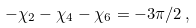<formula> <loc_0><loc_0><loc_500><loc_500>- \chi _ { 2 } - \chi _ { 4 } - \chi _ { 6 } = - { 3 \pi } / { 2 } \, ,</formula> 